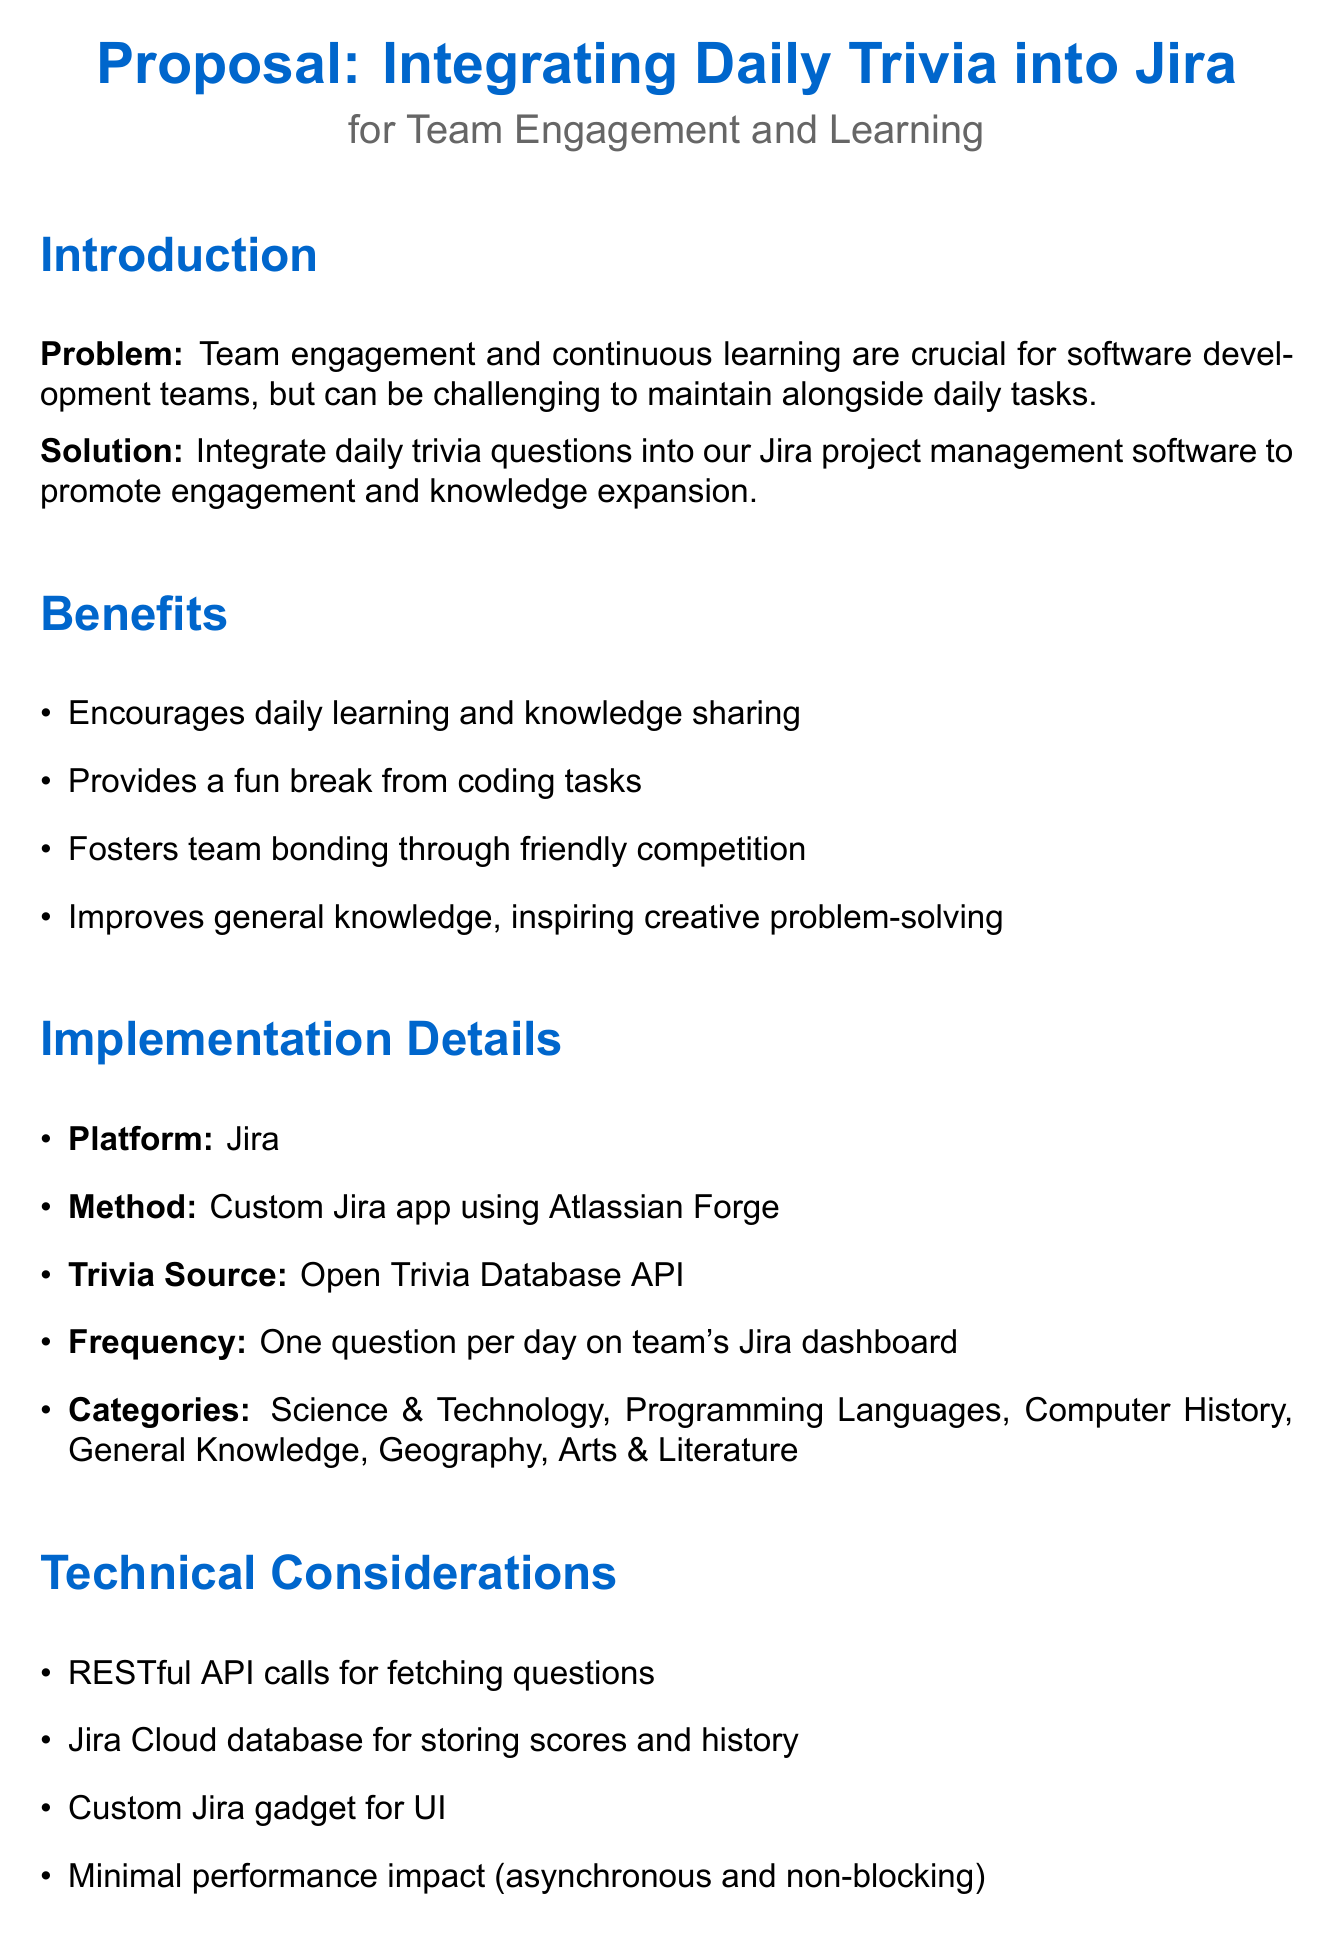What is the main problem stated in the memo? The main problem is related to maintaining team engagement and continuous learning while managing daily tasks.
Answer: Team engagement and continuous learning What is the proposed solution to the problem? The proposed solution is to integrate daily trivia questions into Jira to enhance engagement and knowledge.
Answer: Integrate daily trivia questions into Jira What is the frequency of trivia questions posted? This refers to how often trivia questions will be made available to the team through Jira.
Answer: One question per day How many hours are estimated for initial setup and integration? This number reflects the total estimated development time needed to set up the trivia integration.
Answer: 40 hours What are the categories of trivia questions mentioned? The categories encompass various subjects from which the trivia questions will be derived.
Answer: Science & Technology, Programming Languages, Computer History, General Knowledge, Geography, Arts & Literature What aspect of participation will be tracked in the pilot program? This pertains to the different metrics used to evaluate how well team members engage with the trivia.
Answer: Daily participation rate What is one potential challenge mentioned in the memo? This refers to issues that could arise in the implementation or maintenance of the trivia initiative.
Answer: Ensuring trivia questions are diverse and engaging What will be displayed on the team's Jira dashboard? This addresses what content will be visible to the team in relation to the trivia activity.
Answer: Weekly and monthly rankings What type of app will be developed for integration? This specifies the kind of application that will be created to merge trivia functionality with Jira.
Answer: Custom Jira app 